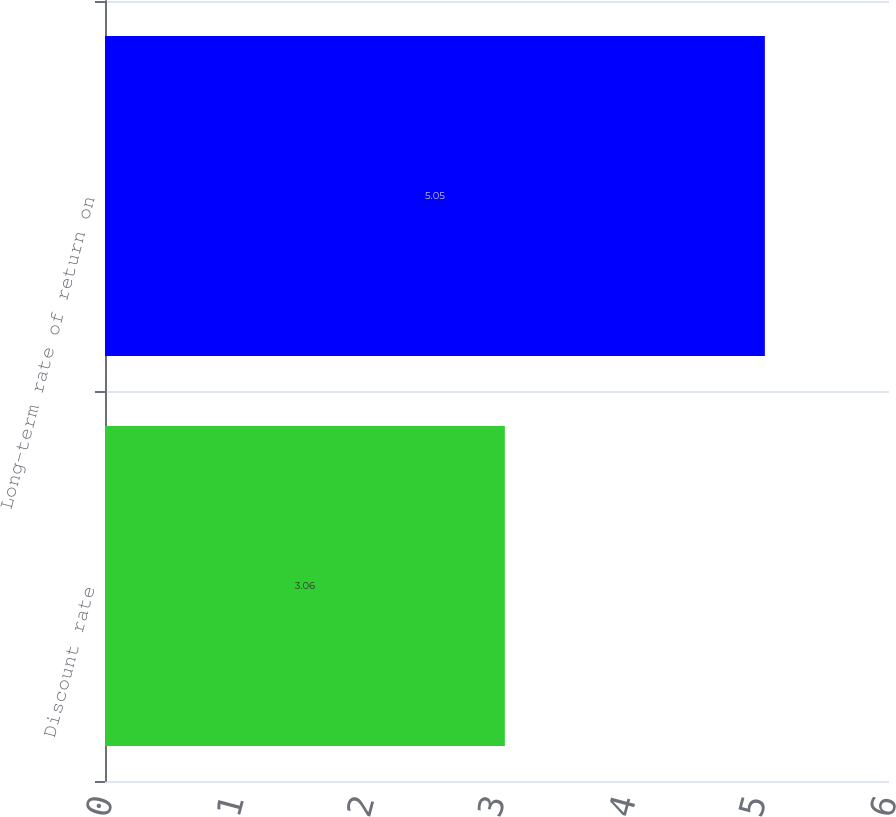Convert chart to OTSL. <chart><loc_0><loc_0><loc_500><loc_500><bar_chart><fcel>Discount rate<fcel>Long-term rate of return on<nl><fcel>3.06<fcel>5.05<nl></chart> 